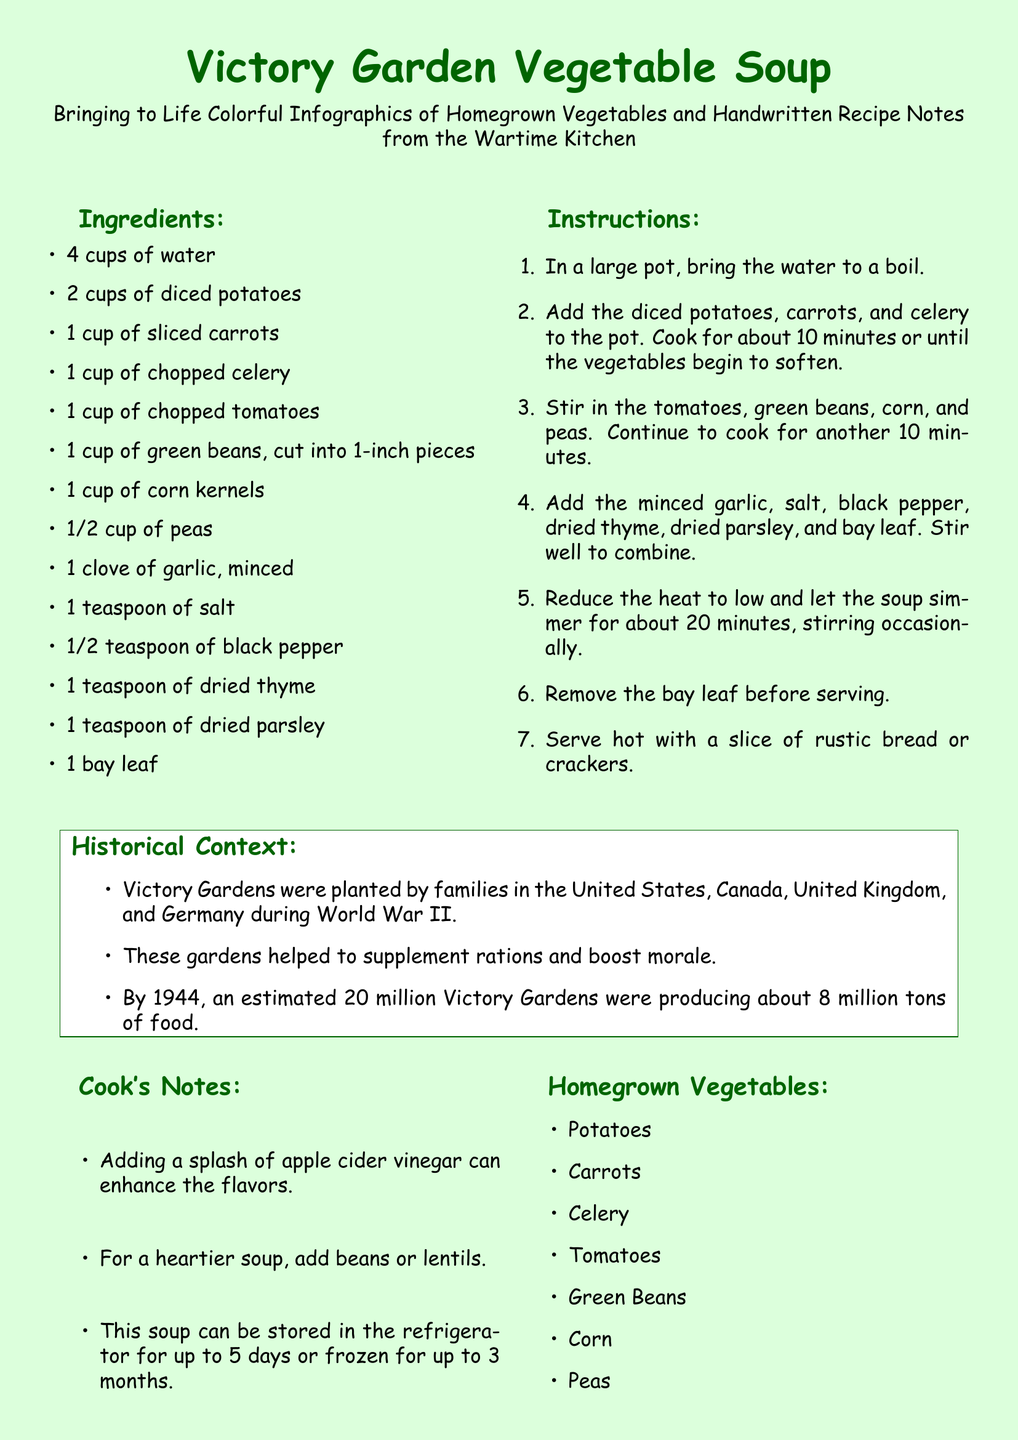what is the title of the recipe card? The title of the recipe card is prominently displayed at the top of the document.
Answer: Victory Garden Vegetable Soup how many cups of water are required? The document lists the ingredients along with their quantities.
Answer: 4 cups what is one optional ingredient suggested for enhancing flavors? The cook's notes provide suggestions for making the soup tastier.
Answer: apple cider vinegar how long should the soup simmer? The instructions detail the cooking times for different steps in the recipe.
Answer: 20 minutes what year were an estimated 20 million Victory Gardens producing food? The historical context offers specific historical data related to Victory Gardens.
Answer: 1944 how many vegetables are listed under homegrown vegetables? The document provides a list of vegetables that can be grown at home.
Answer: 7 what type of bread is recommended to serve with the soup? The final serving suggestion is provided in the instructions of the recipe.
Answer: rustic bread what are two types of beans or lentils that can be added for a heartier soup? The cook's notes suggest making the soup heartier with certain ingredients.
Answer: beans or lentils what is the main color of the page background? The document specifies the overall design and color choices.
Answer: light green 